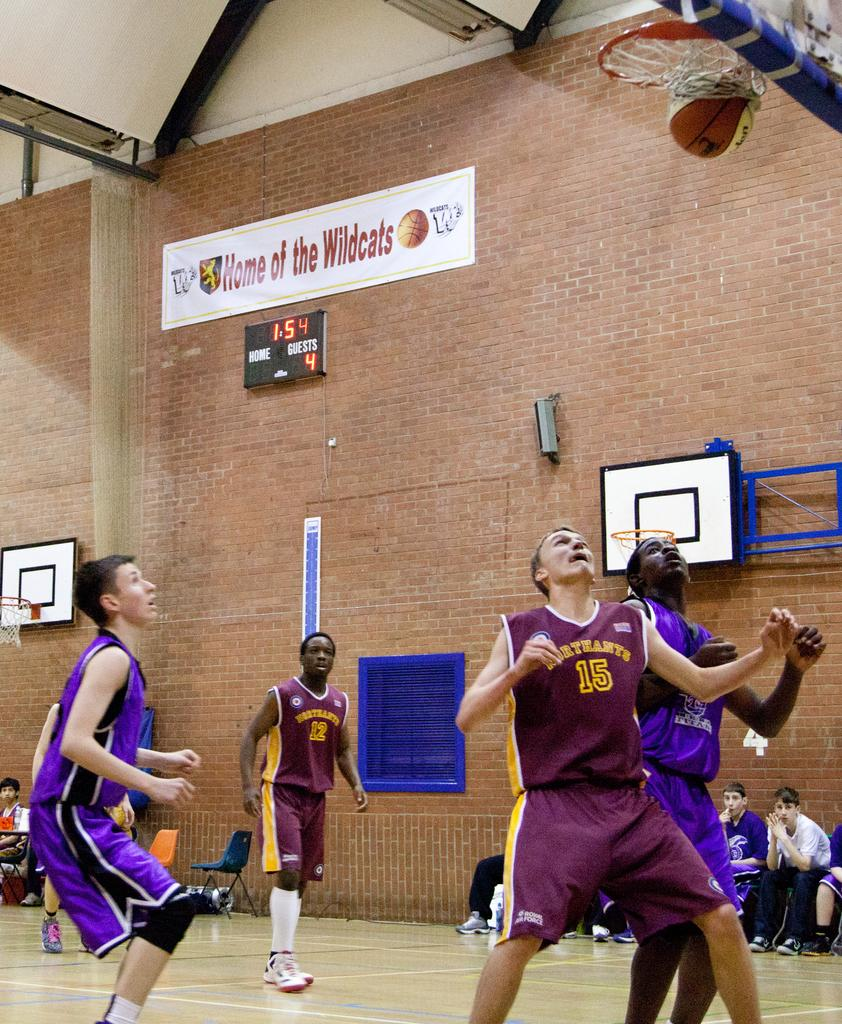<image>
Give a short and clear explanation of the subsequent image. A player in a maroon shirt with the number 15 on it waiting for the ball 